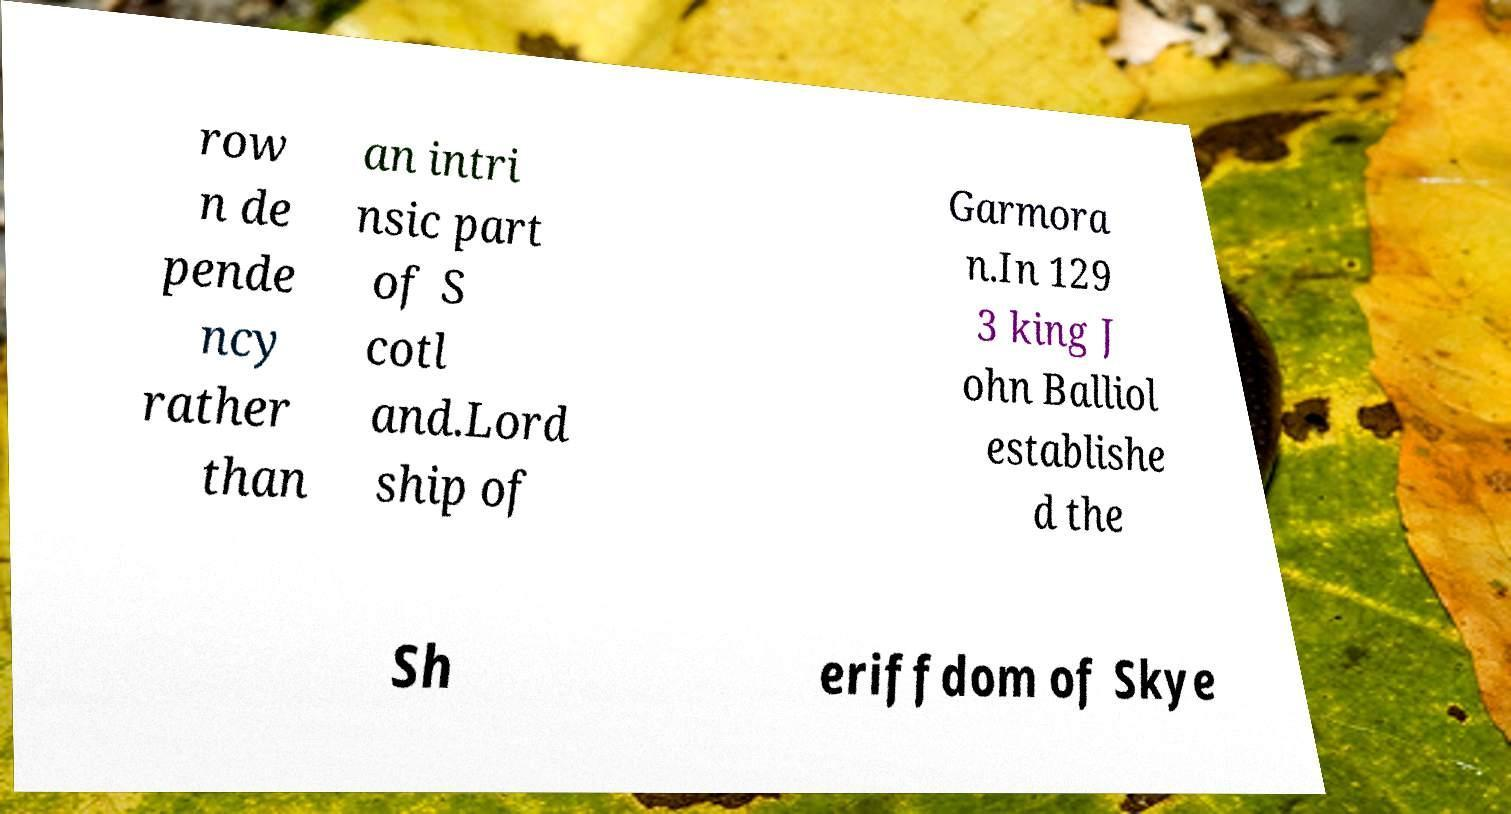What messages or text are displayed in this image? I need them in a readable, typed format. row n de pende ncy rather than an intri nsic part of S cotl and.Lord ship of Garmora n.In 129 3 king J ohn Balliol establishe d the Sh eriffdom of Skye 